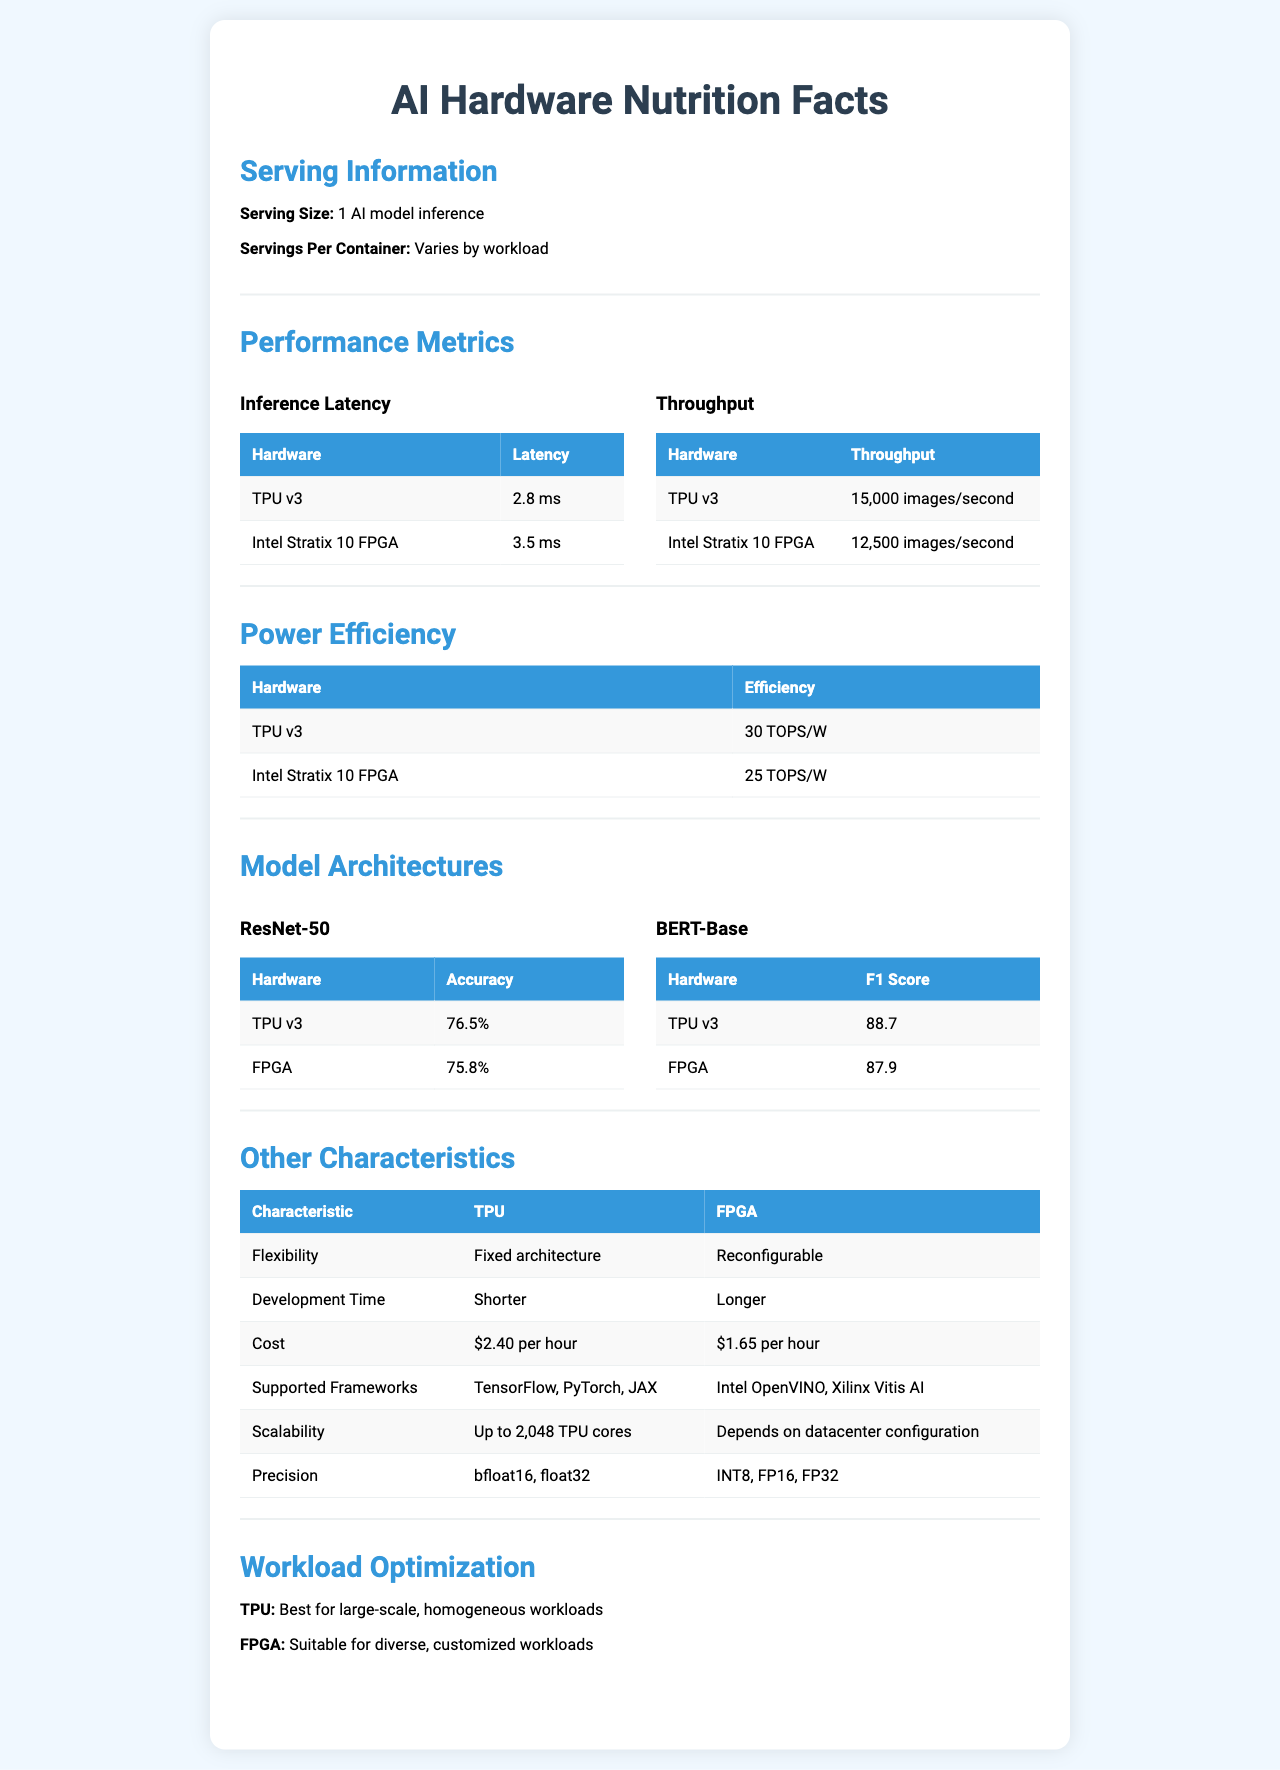what is the serving size? The serving size is mentioned in the "Serving Information" section under "Serving Size".
Answer: 1 AI model inference what is the throughput of TPU v3? The throughput of TPU v3 is specified in the "Performance Metrics" section under "Throughput".
Answer: 15,000 images/second what is the power efficiency of Intel Stratix 10 FPGA? The power efficiency of Intel Stratix 10 FPGA can be found in the "Power Efficiency" section.
Answer: 25 TOPS/W what is the cost of using an AWS F1 Instance (FPGA)? The cost for using an AWS F1 Instance (FPGA) is detailed under "Cost" in the "Other Characteristics" section.
Answer: $1.65 per hour which model architecture has a higher accuracy for TPU v3? ResNet-50 or BERT-Base According to the "Model Architectures" section, TPU v3 has an accuracy of 76.5% for ResNet-50 and an F1 score of 88.7 for BERT-Base, indicating higher accuracy for ResNet-50.
Answer: ResNet-50 which hardware has lower inference latency? A. TPU v3 B. Intel Stratix 10 FPGA TPU v3 has a lower inference latency of 2.8 ms compared to Intel Stratix 10 FPGA's 3.5 ms, as shown in the "Performance Metrics" section.
Answer: A which frameworks are supported by TPU? 1. TensorFlow 2. PyTorch 3. JAX 4. Vitis AI According to the "Supported Frameworks" section, TPU supports TensorFlow, PyTorch, and JAX, but not Vitis AI.
Answer: 1, 2, 3 is FPGA reconfigurable? The "Flexibility" section indicates that FPGA is reconfigurable.
Answer: Yes summarize the main differences between TPU v3 and Intel Stratix 10 FPGA. TPUs show higher performance in speed metrics and power efficiency but come with a fixed architecture and higher cost, whereas FPGAs offer more flexibility and are suitable for custom workloads but require longer development time.
Answer: TPUs are optimized for speed with lower latency, higher throughput, and more power efficiency but are less flexible and more costly for development, while FPGAs offer reconfigurability and support more diverse workloads at a lower hourly cost. what is the difference in scalability for TPU and FPGA? The scalability details are found in the "Scalability" section under "Other Characteristics," where TPU scales up to 2,048 cores, and FPGA's scalability varies with datacenter configuration.
Answer: TPU scalability is up to 2,048 TPU cores, while FPGA scalability depends on datacenter configuration. what specific optimization is TPU best suited for? The "Workload Optimization" section notes that TPUs are best for large-scale, homogeneous workloads.
Answer: Large-scale, homogeneous workloads how much development time does it take for TPU compared to FPGA? The "Development Time" section states that it takes a shorter time to develop on TPU compared to FPGA.
Answer: Shorter for TPU, longer for FPGA which precision formats do Intel Stratix 10 FPGA support? The "Precision" section helps identify that Intel Stratix 10 FPGA supports INT8, FP16, and FP32 formats.
Answer: INT8, FP16, FP32 what is the efficiency difference between TPU v3 and FPGA? TPU v3 offers an efficiency of 30 TOPS/W, while FPGA offers 25 TOPS/W, resulting in a difference of 5 TOPS/W.
Answer: 5 TOPS/W what is the main idea of the document provided? This summary describes the overall comparison between TPU v3 and Intel Stratix 10 FPGA across multiple dimensions of AI model deployment.
Answer: The document is an AI Hardware Nutrition Facts Label that compares various aspects, including performance, efficiency, cost, scalability, and flexibility, of TPU v3 and Intel Stratix 10 FPGA for different AI model architectures. what are the training times for both TPU v3 and FPGA? The document does not provide any details about the training times for either TPU v3 or FPGA.
Answer: Not enough information 